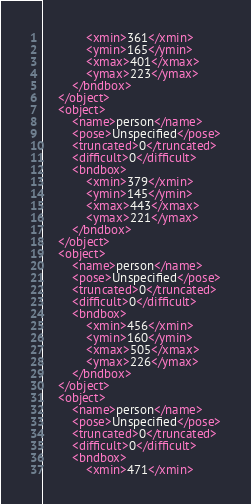Convert code to text. <code><loc_0><loc_0><loc_500><loc_500><_XML_>			<xmin>361</xmin>
			<ymin>165</ymin>
			<xmax>401</xmax>
			<ymax>223</ymax>
		</bndbox>
	</object>
	<object>
		<name>person</name>
		<pose>Unspecified</pose>
		<truncated>0</truncated>
		<difficult>0</difficult>
		<bndbox>
			<xmin>379</xmin>
			<ymin>145</ymin>
			<xmax>443</xmax>
			<ymax>221</ymax>
		</bndbox>
	</object>
	<object>
		<name>person</name>
		<pose>Unspecified</pose>
		<truncated>0</truncated>
		<difficult>0</difficult>
		<bndbox>
			<xmin>456</xmin>
			<ymin>160</ymin>
			<xmax>505</xmax>
			<ymax>226</ymax>
		</bndbox>
	</object>
	<object>
		<name>person</name>
		<pose>Unspecified</pose>
		<truncated>0</truncated>
		<difficult>0</difficult>
		<bndbox>
			<xmin>471</xmin></code> 